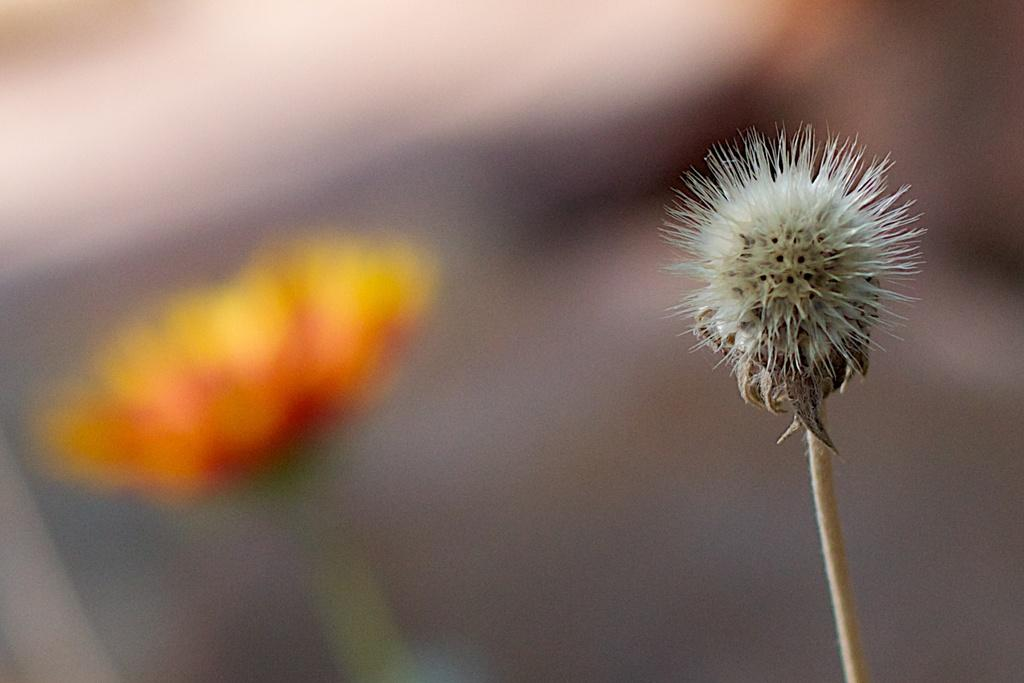What is the main subject in the foreground of the image? There is a flower in the foreground of the image. Can you describe the background of the image? There is another flower in the background of the image. How many flowers are visible in the image? There are two flowers visible in the image, one in the foreground and one in the background. What type of gun is being used to cast a shadow on the flowers in the image? There is no gun or shadow present in the image; it features two flowers, one in the foreground and one in the background. 